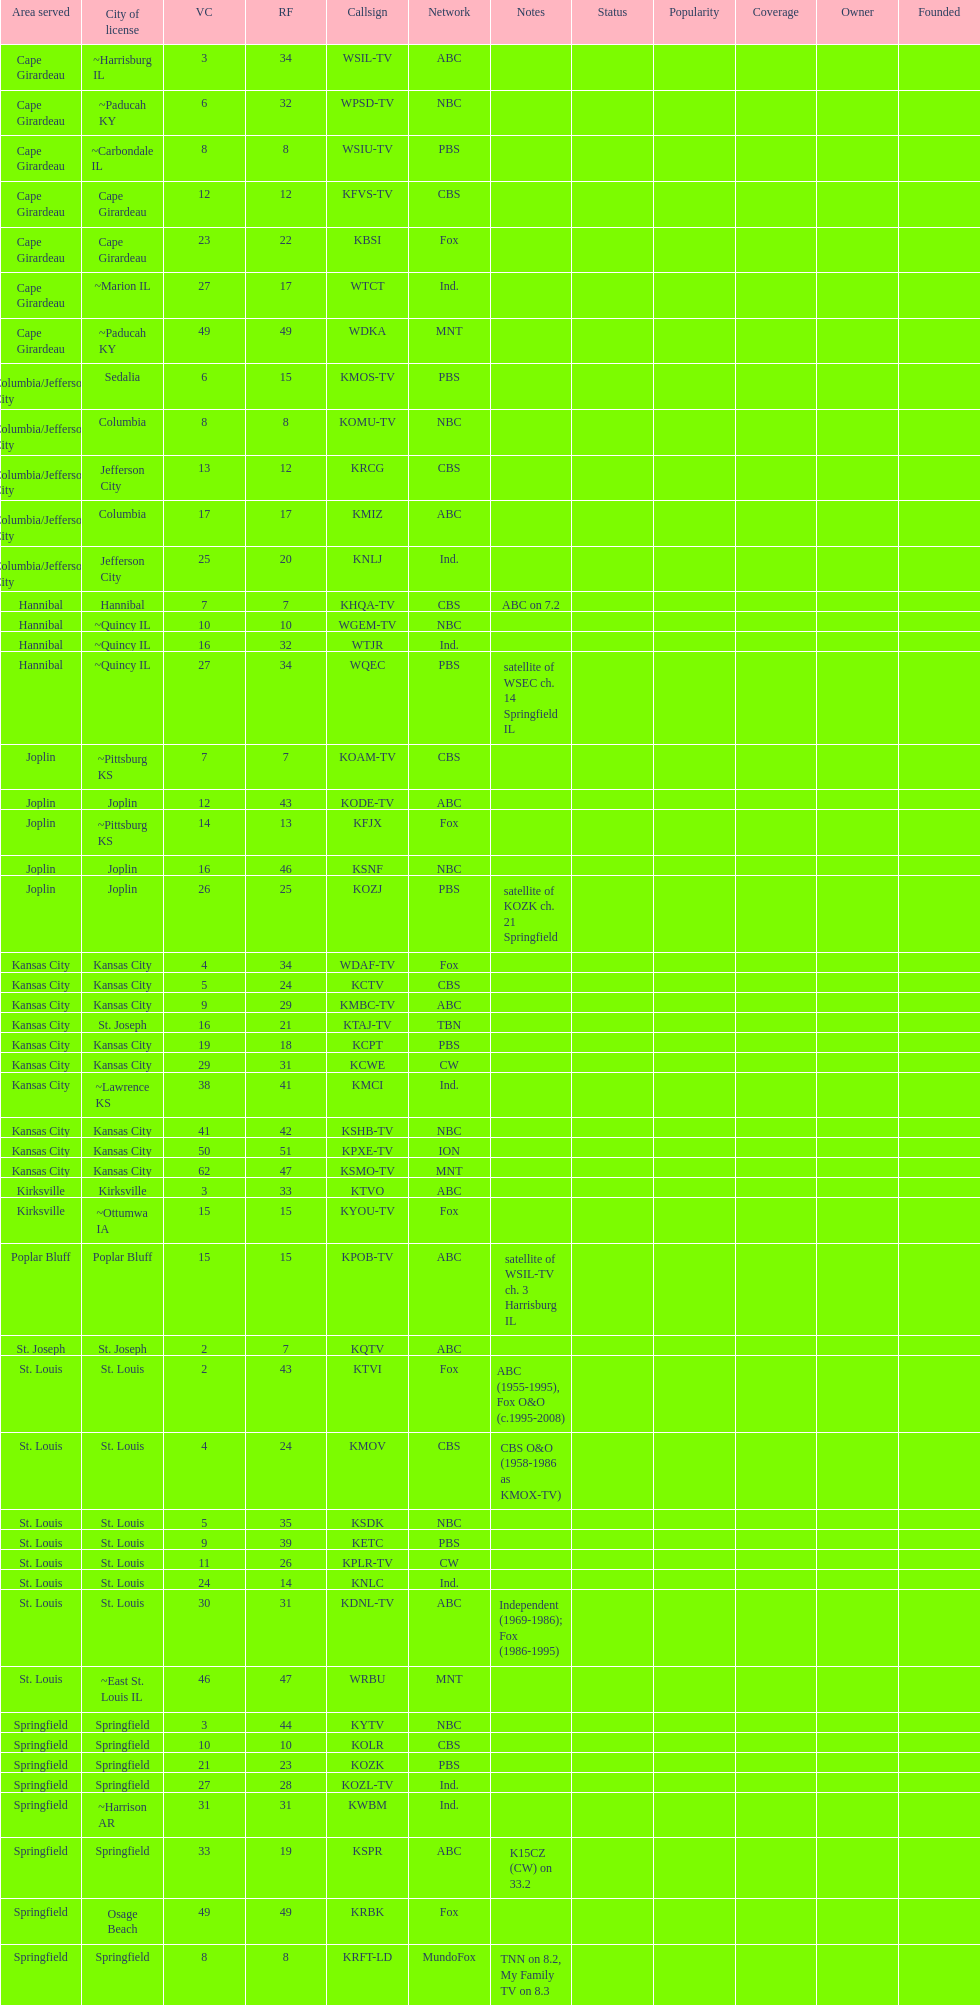How many people are associated with the cbs network? 7. 